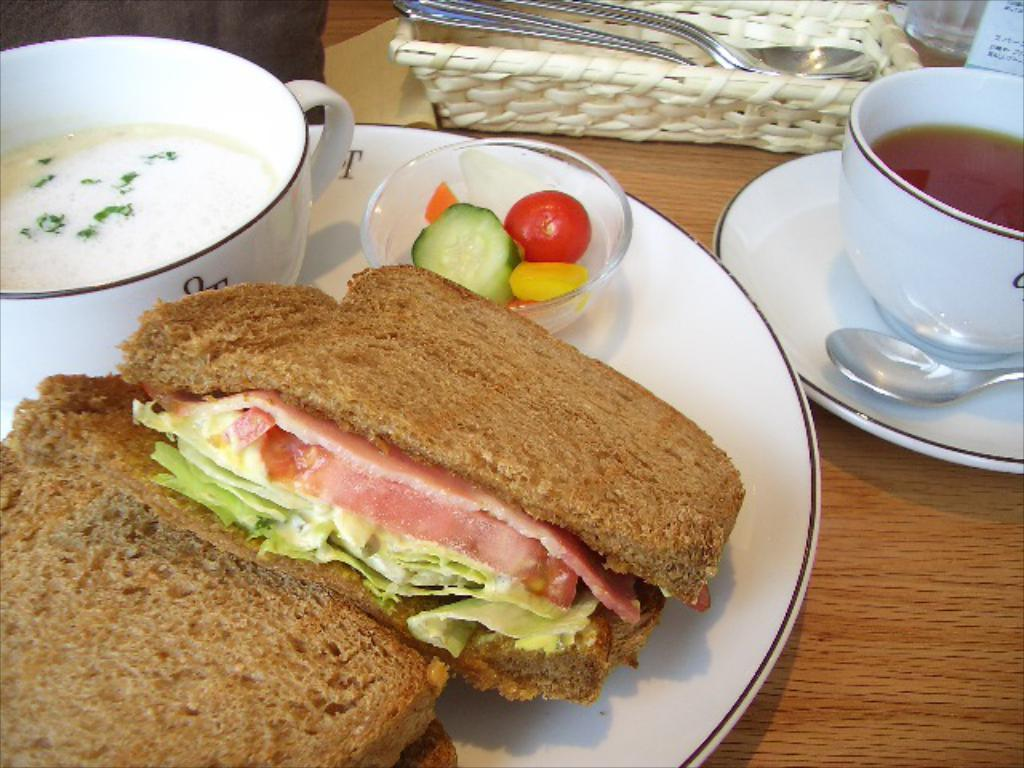What is the main object in the center of the image? There is a table in the center of the image. What items can be seen on the table? There are plates, cups, bowls, spoons, and food items on the table. What else is present on the table? There is a basket on the table. What type of trade is being conducted on the table in the image? There is no trade being conducted on the table in the image; it is a table with various items placed on it. What power source is used to operate the channel in the image? There is no channel or power source present in the image; it is a table with various items placed on it. 